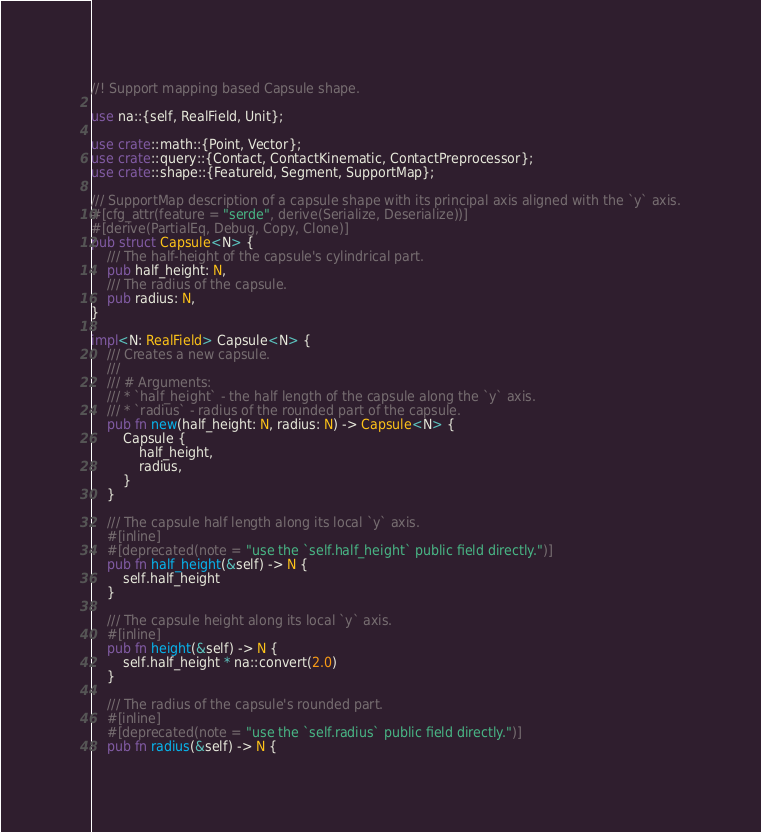<code> <loc_0><loc_0><loc_500><loc_500><_Rust_>//! Support mapping based Capsule shape.

use na::{self, RealField, Unit};

use crate::math::{Point, Vector};
use crate::query::{Contact, ContactKinematic, ContactPreprocessor};
use crate::shape::{FeatureId, Segment, SupportMap};

/// SupportMap description of a capsule shape with its principal axis aligned with the `y` axis.
#[cfg_attr(feature = "serde", derive(Serialize, Deserialize))]
#[derive(PartialEq, Debug, Copy, Clone)]
pub struct Capsule<N> {
    /// The half-height of the capsule's cylindrical part.
    pub half_height: N,
    /// The radius of the capsule.
    pub radius: N,
}

impl<N: RealField> Capsule<N> {
    /// Creates a new capsule.
    ///
    /// # Arguments:
    /// * `half_height` - the half length of the capsule along the `y` axis.
    /// * `radius` - radius of the rounded part of the capsule.
    pub fn new(half_height: N, radius: N) -> Capsule<N> {
        Capsule {
            half_height,
            radius,
        }
    }

    /// The capsule half length along its local `y` axis.
    #[inline]
    #[deprecated(note = "use the `self.half_height` public field directly.")]
    pub fn half_height(&self) -> N {
        self.half_height
    }

    /// The capsule height along its local `y` axis.
    #[inline]
    pub fn height(&self) -> N {
        self.half_height * na::convert(2.0)
    }

    /// The radius of the capsule's rounded part.
    #[inline]
    #[deprecated(note = "use the `self.radius` public field directly.")]
    pub fn radius(&self) -> N {</code> 